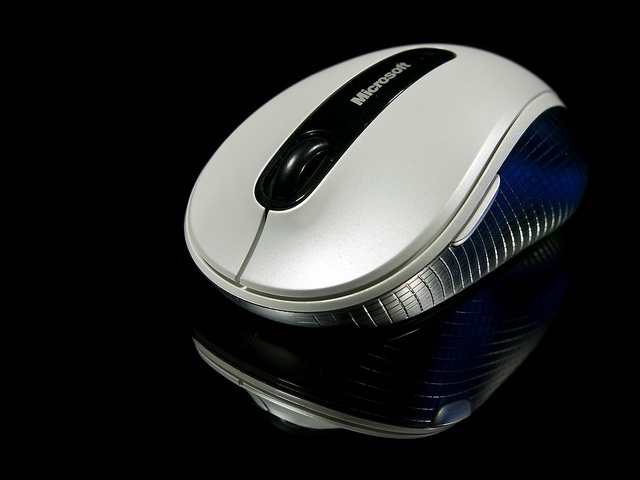Describe the objects in this image and their specific colors. I can see a mouse in black, lightgray, and darkgray tones in this image. 